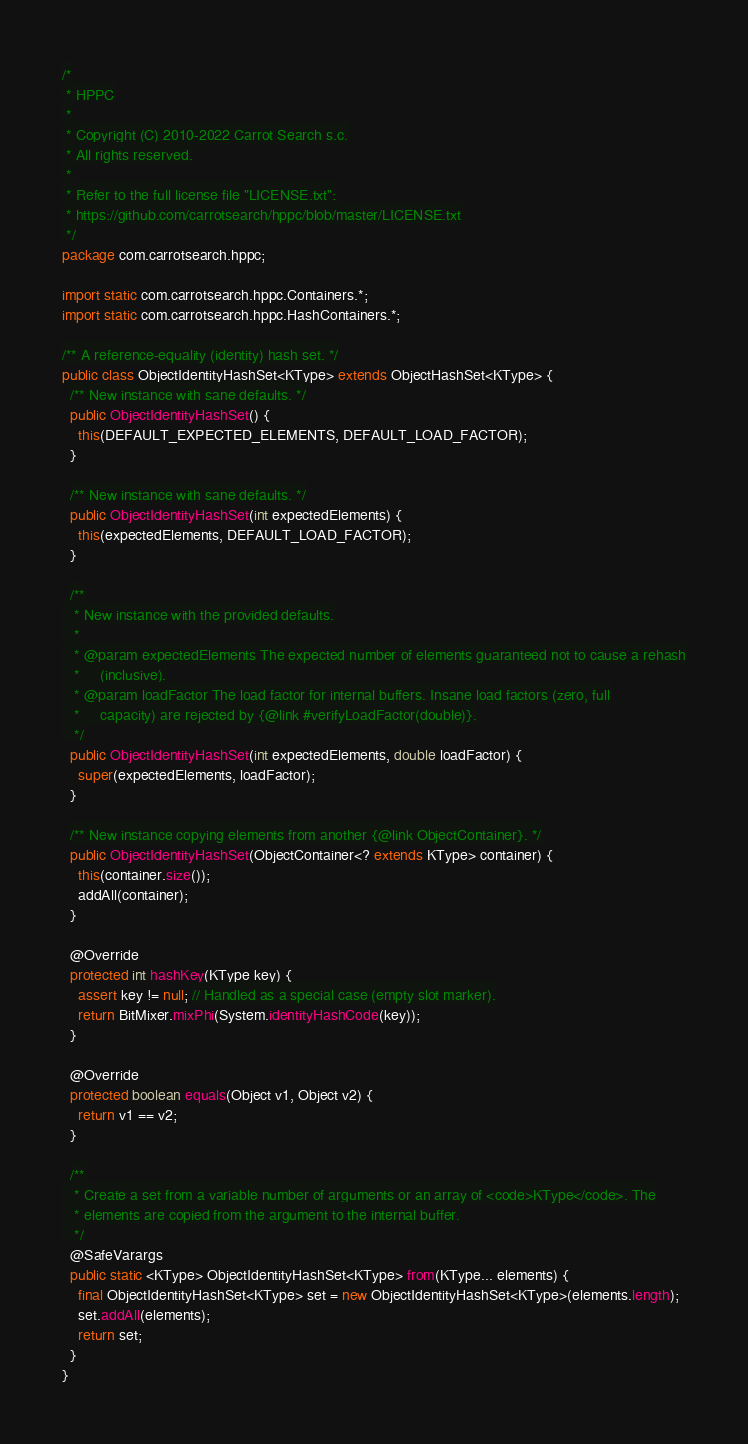Convert code to text. <code><loc_0><loc_0><loc_500><loc_500><_Java_>/*
 * HPPC
 *
 * Copyright (C) 2010-2022 Carrot Search s.c.
 * All rights reserved.
 *
 * Refer to the full license file "LICENSE.txt":
 * https://github.com/carrotsearch/hppc/blob/master/LICENSE.txt
 */
package com.carrotsearch.hppc;

import static com.carrotsearch.hppc.Containers.*;
import static com.carrotsearch.hppc.HashContainers.*;

/** A reference-equality (identity) hash set. */
public class ObjectIdentityHashSet<KType> extends ObjectHashSet<KType> {
  /** New instance with sane defaults. */
  public ObjectIdentityHashSet() {
    this(DEFAULT_EXPECTED_ELEMENTS, DEFAULT_LOAD_FACTOR);
  }

  /** New instance with sane defaults. */
  public ObjectIdentityHashSet(int expectedElements) {
    this(expectedElements, DEFAULT_LOAD_FACTOR);
  }

  /**
   * New instance with the provided defaults.
   *
   * @param expectedElements The expected number of elements guaranteed not to cause a rehash
   *     (inclusive).
   * @param loadFactor The load factor for internal buffers. Insane load factors (zero, full
   *     capacity) are rejected by {@link #verifyLoadFactor(double)}.
   */
  public ObjectIdentityHashSet(int expectedElements, double loadFactor) {
    super(expectedElements, loadFactor);
  }

  /** New instance copying elements from another {@link ObjectContainer}. */
  public ObjectIdentityHashSet(ObjectContainer<? extends KType> container) {
    this(container.size());
    addAll(container);
  }

  @Override
  protected int hashKey(KType key) {
    assert key != null; // Handled as a special case (empty slot marker).
    return BitMixer.mixPhi(System.identityHashCode(key));
  }

  @Override
  protected boolean equals(Object v1, Object v2) {
    return v1 == v2;
  }

  /**
   * Create a set from a variable number of arguments or an array of <code>KType</code>. The
   * elements are copied from the argument to the internal buffer.
   */
  @SafeVarargs
  public static <KType> ObjectIdentityHashSet<KType> from(KType... elements) {
    final ObjectIdentityHashSet<KType> set = new ObjectIdentityHashSet<KType>(elements.length);
    set.addAll(elements);
    return set;
  }
}
</code> 